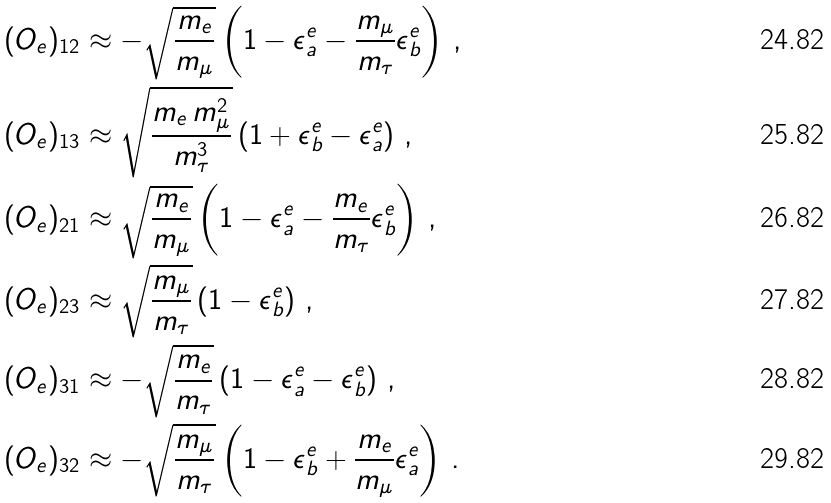<formula> <loc_0><loc_0><loc_500><loc_500>( O _ { e } ) _ { 1 2 } & \approx - \sqrt { \frac { m _ { e } } { m _ { \mu } } } \left ( 1 - \epsilon ^ { e } _ { a } - \frac { m _ { \mu } } { m _ { \tau } } \epsilon ^ { e } _ { b } \right ) \, , \\ ( O _ { e } ) _ { 1 3 } & \approx \sqrt { \frac { m _ { e } \, m _ { \mu } ^ { 2 } } { m _ { \tau } ^ { 3 } } } \left ( 1 + \epsilon ^ { e } _ { b } - \epsilon ^ { e } _ { a } \right ) \, , \\ ( O _ { e } ) _ { 2 1 } & \approx \sqrt { \frac { m _ { e } } { m _ { \mu } } } \left ( 1 - \epsilon ^ { e } _ { a } - \frac { m _ { e } } { m _ { \tau } } \epsilon ^ { e } _ { b } \right ) \, , \\ ( O _ { e } ) _ { 2 3 } & \approx \sqrt { \frac { m _ { \mu } } { m _ { \tau } } } \left ( 1 - \epsilon ^ { e } _ { b } \right ) \, , \\ ( O _ { e } ) _ { 3 1 } & \approx - \sqrt { \frac { m _ { e } } { m _ { \tau } } } \left ( 1 - \epsilon ^ { e } _ { a } - \epsilon ^ { e } _ { b } \right ) \, , \\ ( O _ { e } ) _ { 3 2 } & \approx - \sqrt { \frac { m _ { \mu } } { m _ { \tau } } } \left ( 1 - \epsilon ^ { e } _ { b } + \frac { m _ { e } } { m _ { \mu } } \epsilon ^ { e } _ { a } \right ) \, .</formula> 